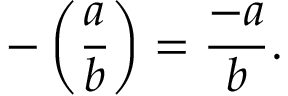Convert formula to latex. <formula><loc_0><loc_0><loc_500><loc_500>- \left ( { \frac { a } { b } } \right ) = { \frac { - a } { b } } .</formula> 